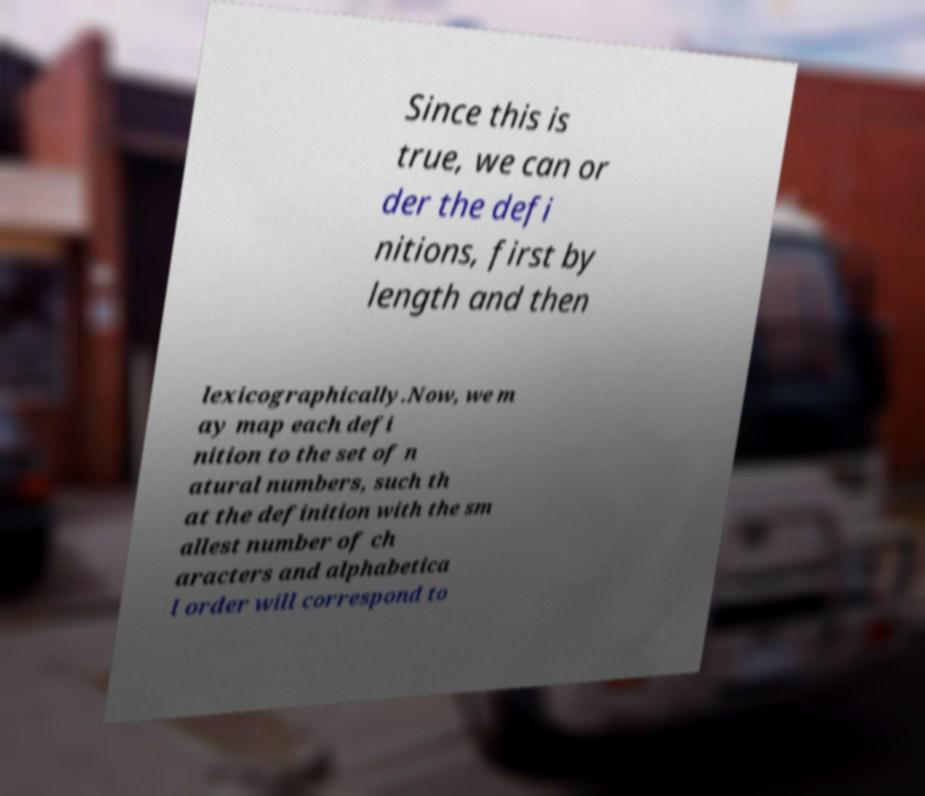There's text embedded in this image that I need extracted. Can you transcribe it verbatim? Since this is true, we can or der the defi nitions, first by length and then lexicographically.Now, we m ay map each defi nition to the set of n atural numbers, such th at the definition with the sm allest number of ch aracters and alphabetica l order will correspond to 